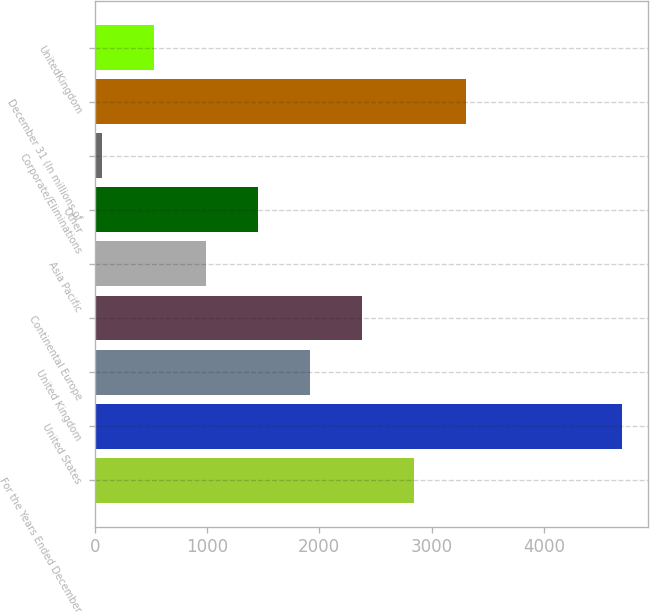Convert chart. <chart><loc_0><loc_0><loc_500><loc_500><bar_chart><fcel>For the Years Ended December<fcel>United States<fcel>United Kingdom<fcel>Continental Europe<fcel>Asia Pacific<fcel>Other<fcel>Corporate/Eliminations<fcel>December 31 (In millions of<fcel>UnitedKingdom<nl><fcel>2843.6<fcel>4694<fcel>1918.4<fcel>2381<fcel>993.2<fcel>1455.8<fcel>68<fcel>3306.2<fcel>530.6<nl></chart> 